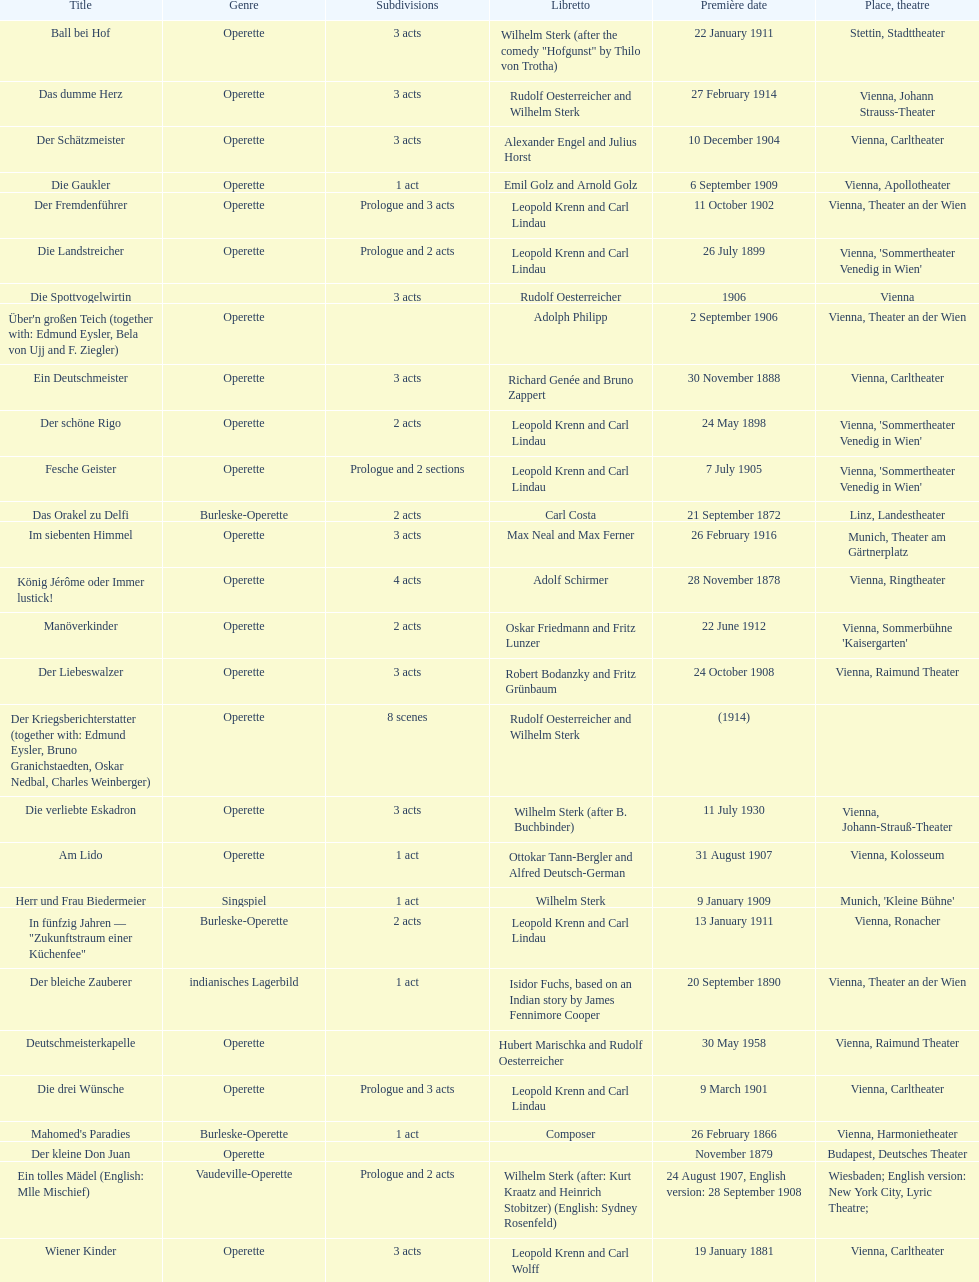In which city did the most operettas premiere? Vienna. 